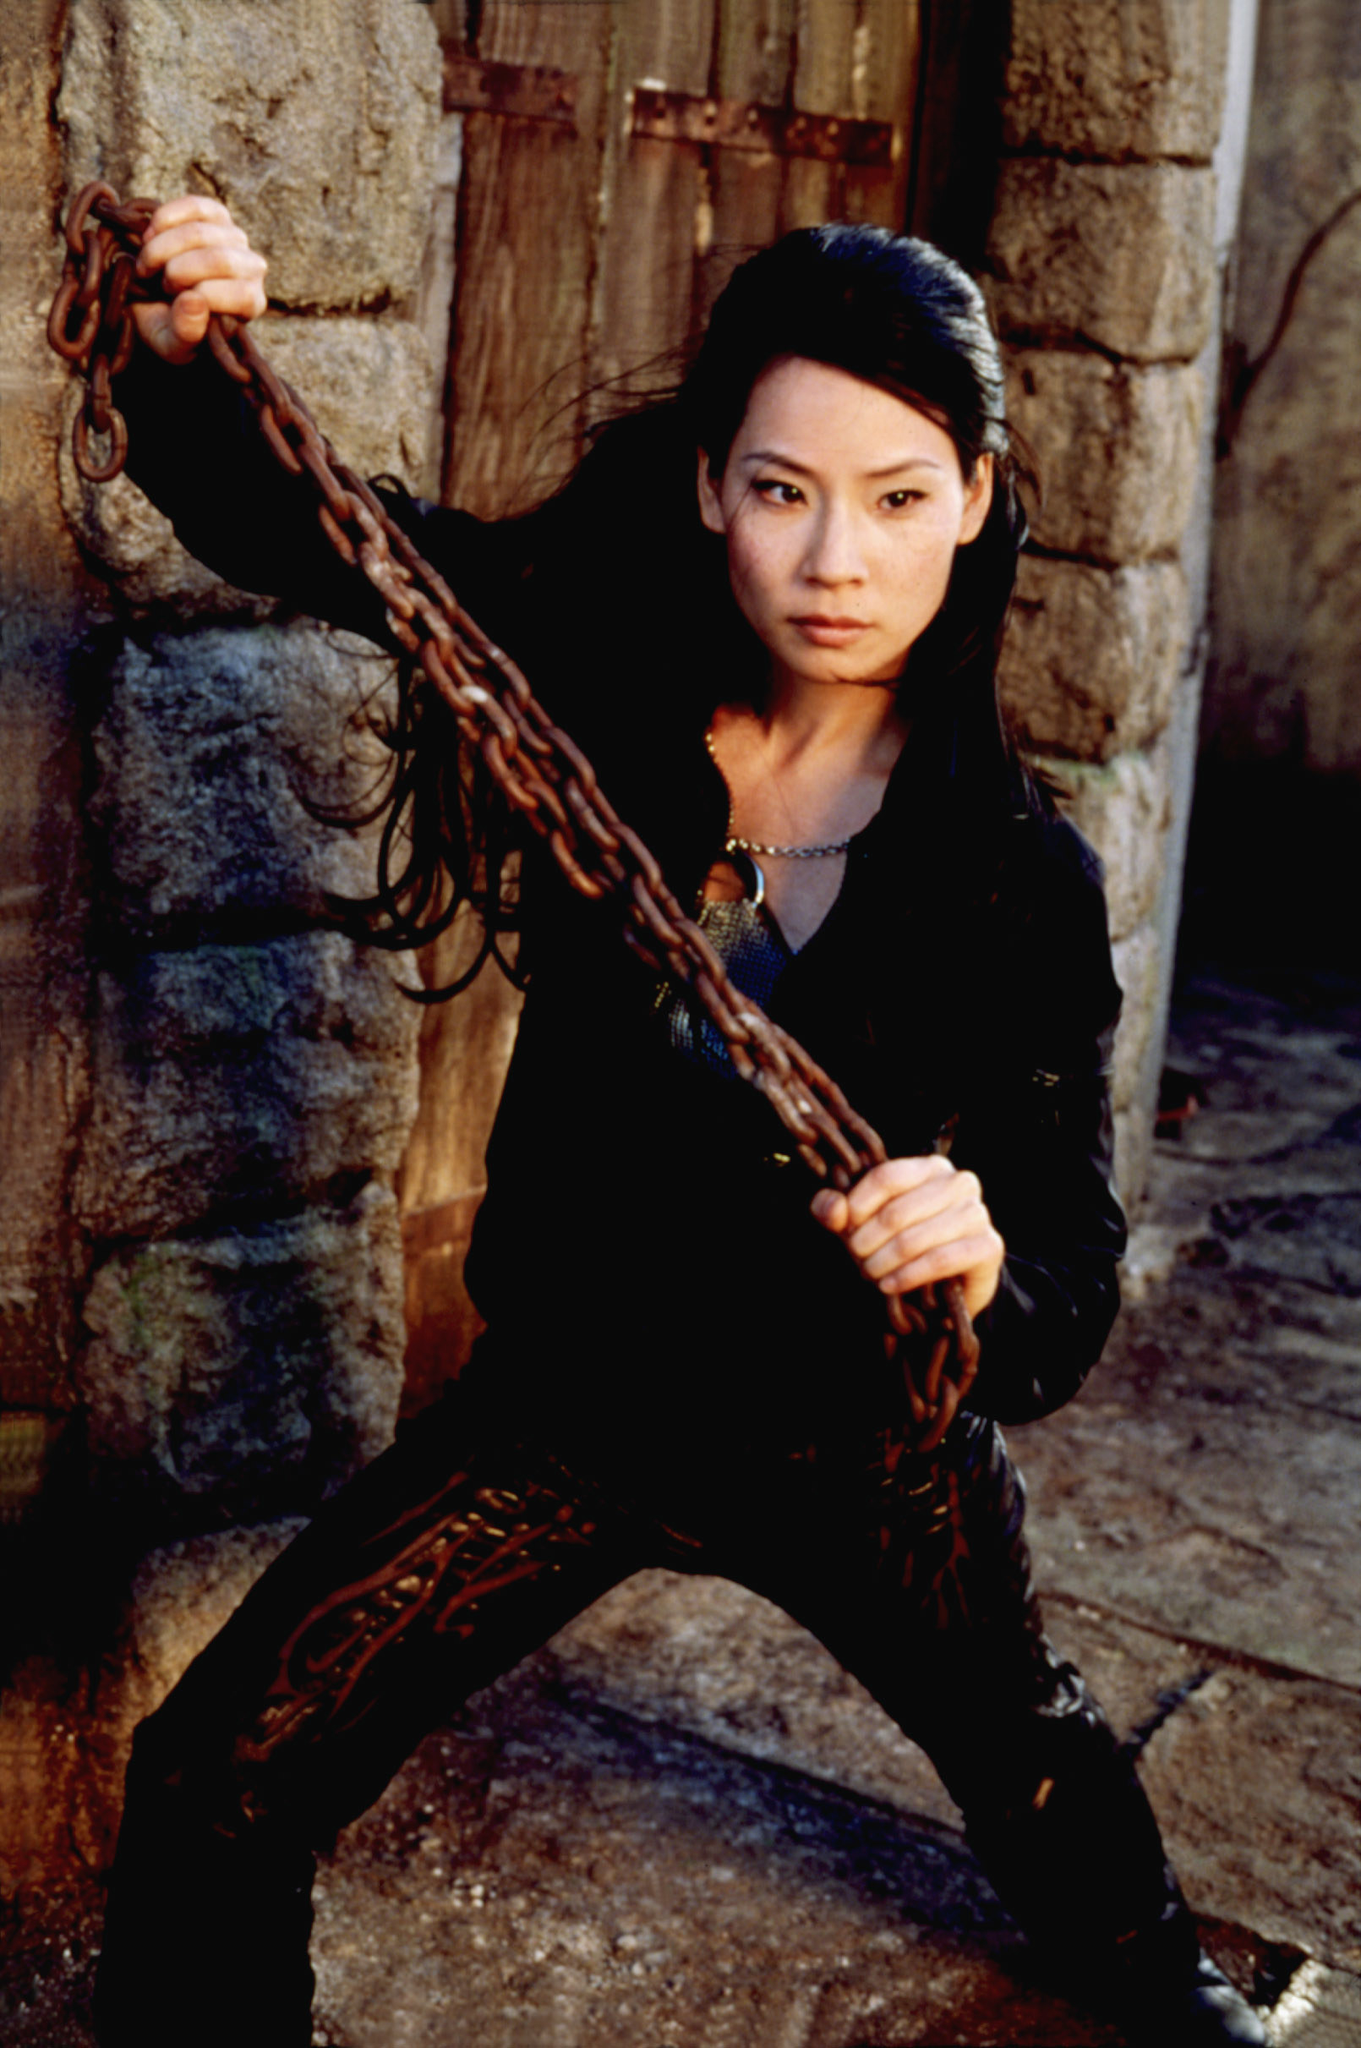What is this photo about? The image shows a dramatic scene featuring a character from the movie Charlie's Angels. The actress, portraying the role of Alex Munday, stands in a confident and assertive stance in front of a stone wall and a wooden door. She grips a heavy chain with her left hand, ready for action, while her right hand rests on her hip. Her outfit consists of a sleek black jacket and pants, complemented by a striking red necklace. The overall composition and her determined expression capture the strength and resilience of her character. 